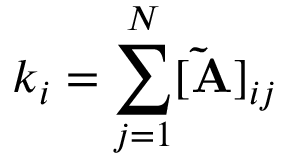Convert formula to latex. <formula><loc_0><loc_0><loc_500><loc_500>k _ { i } = \sum _ { j = 1 } ^ { N } [ \tilde { A } ] _ { i j }</formula> 